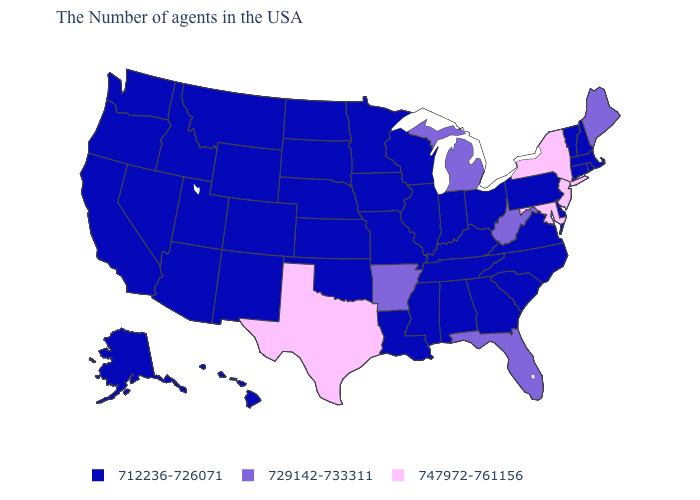Name the states that have a value in the range 747972-761156?
Quick response, please. New York, New Jersey, Maryland, Texas. Which states have the lowest value in the USA?
Keep it brief. Massachusetts, Rhode Island, New Hampshire, Vermont, Connecticut, Delaware, Pennsylvania, Virginia, North Carolina, South Carolina, Ohio, Georgia, Kentucky, Indiana, Alabama, Tennessee, Wisconsin, Illinois, Mississippi, Louisiana, Missouri, Minnesota, Iowa, Kansas, Nebraska, Oklahoma, South Dakota, North Dakota, Wyoming, Colorado, New Mexico, Utah, Montana, Arizona, Idaho, Nevada, California, Washington, Oregon, Alaska, Hawaii. What is the value of Alaska?
Short answer required. 712236-726071. Name the states that have a value in the range 729142-733311?
Answer briefly. Maine, West Virginia, Florida, Michigan, Arkansas. What is the value of Massachusetts?
Give a very brief answer. 712236-726071. Name the states that have a value in the range 729142-733311?
Answer briefly. Maine, West Virginia, Florida, Michigan, Arkansas. How many symbols are there in the legend?
Concise answer only. 3. Does the first symbol in the legend represent the smallest category?
Write a very short answer. Yes. How many symbols are there in the legend?
Be succinct. 3. What is the value of Washington?
Answer briefly. 712236-726071. Among the states that border Florida , which have the highest value?
Answer briefly. Georgia, Alabama. Name the states that have a value in the range 712236-726071?
Answer briefly. Massachusetts, Rhode Island, New Hampshire, Vermont, Connecticut, Delaware, Pennsylvania, Virginia, North Carolina, South Carolina, Ohio, Georgia, Kentucky, Indiana, Alabama, Tennessee, Wisconsin, Illinois, Mississippi, Louisiana, Missouri, Minnesota, Iowa, Kansas, Nebraska, Oklahoma, South Dakota, North Dakota, Wyoming, Colorado, New Mexico, Utah, Montana, Arizona, Idaho, Nevada, California, Washington, Oregon, Alaska, Hawaii. Does New Jersey have the highest value in the USA?
Quick response, please. Yes. What is the highest value in the Northeast ?
Be succinct. 747972-761156. 